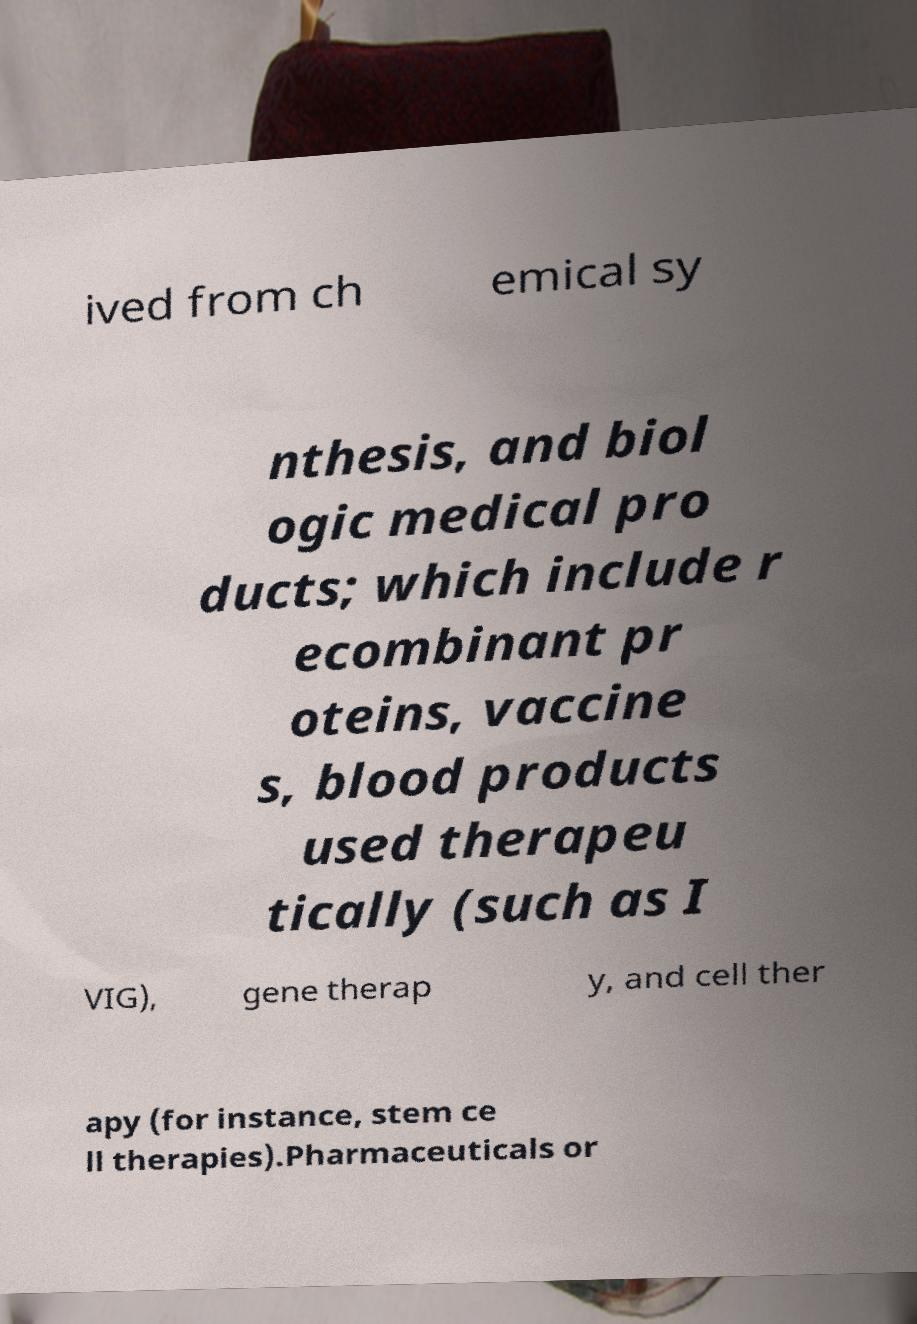Can you accurately transcribe the text from the provided image for me? ived from ch emical sy nthesis, and biol ogic medical pro ducts; which include r ecombinant pr oteins, vaccine s, blood products used therapeu tically (such as I VIG), gene therap y, and cell ther apy (for instance, stem ce ll therapies).Pharmaceuticals or 